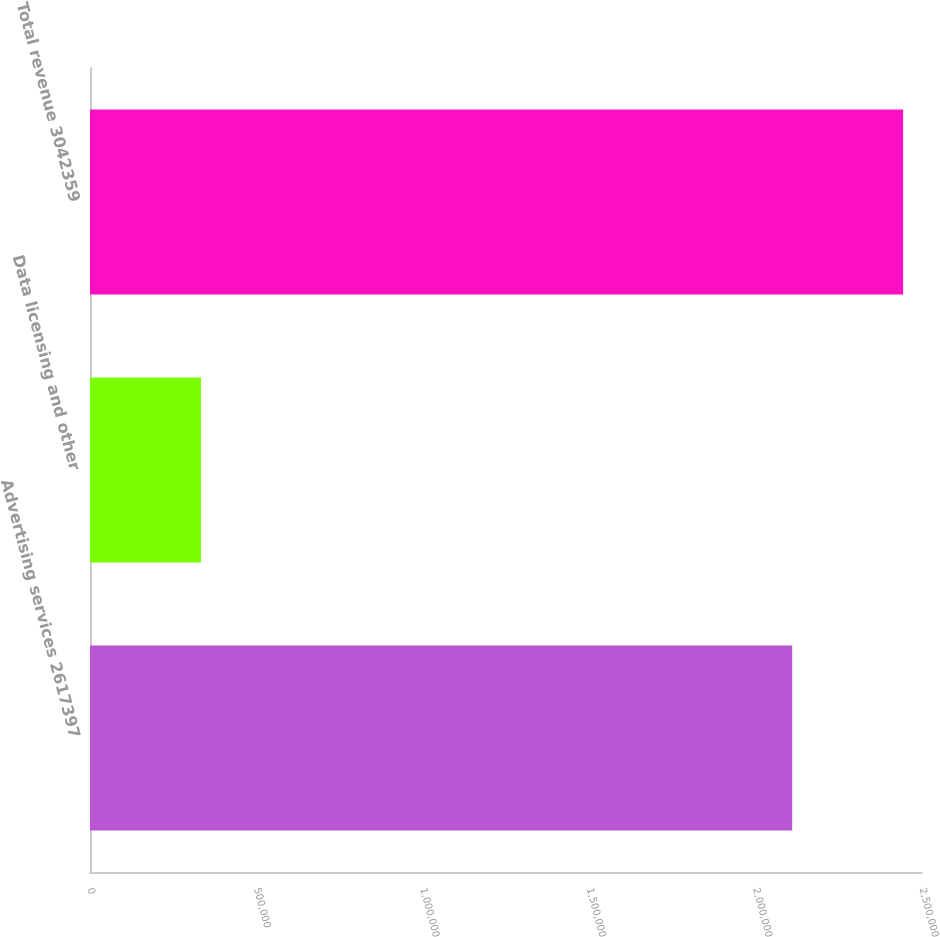Convert chart to OTSL. <chart><loc_0><loc_0><loc_500><loc_500><bar_chart><fcel>Advertising services 2617397<fcel>Data licensing and other<fcel>Total revenue 3042359<nl><fcel>2.10999e+06<fcel>333312<fcel>2.4433e+06<nl></chart> 